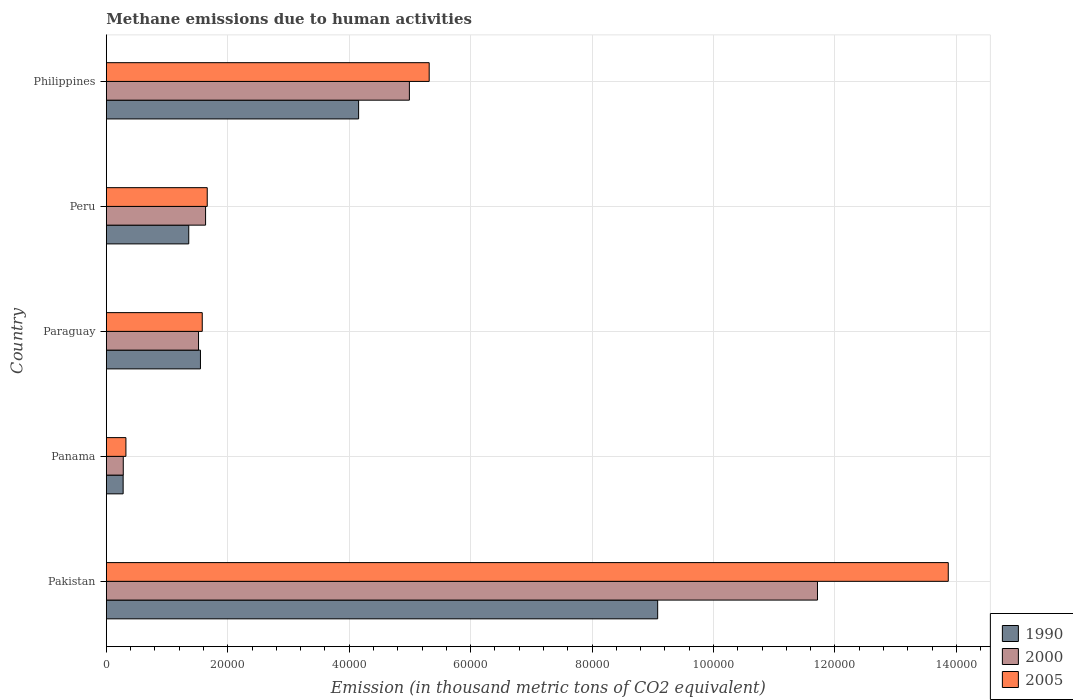How many different coloured bars are there?
Ensure brevity in your answer.  3. How many groups of bars are there?
Offer a very short reply. 5. Are the number of bars per tick equal to the number of legend labels?
Your answer should be compact. Yes. Are the number of bars on each tick of the Y-axis equal?
Your response must be concise. Yes. How many bars are there on the 3rd tick from the bottom?
Offer a very short reply. 3. In how many cases, is the number of bars for a given country not equal to the number of legend labels?
Make the answer very short. 0. What is the amount of methane emitted in 2005 in Pakistan?
Give a very brief answer. 1.39e+05. Across all countries, what is the maximum amount of methane emitted in 2000?
Provide a short and direct response. 1.17e+05. Across all countries, what is the minimum amount of methane emitted in 1990?
Provide a short and direct response. 2769.4. In which country was the amount of methane emitted in 2005 maximum?
Give a very brief answer. Pakistan. In which country was the amount of methane emitted in 2000 minimum?
Ensure brevity in your answer.  Panama. What is the total amount of methane emitted in 2000 in the graph?
Keep it short and to the point. 2.01e+05. What is the difference between the amount of methane emitted in 2000 in Panama and that in Peru?
Provide a succinct answer. -1.36e+04. What is the difference between the amount of methane emitted in 2000 in Peru and the amount of methane emitted in 1990 in Paraguay?
Your answer should be compact. 844.3. What is the average amount of methane emitted in 1990 per country?
Provide a short and direct response. 3.28e+04. What is the difference between the amount of methane emitted in 2000 and amount of methane emitted in 2005 in Panama?
Offer a terse response. -436. In how many countries, is the amount of methane emitted in 2005 greater than 140000 thousand metric tons?
Provide a short and direct response. 0. What is the ratio of the amount of methane emitted in 2000 in Panama to that in Paraguay?
Your answer should be very brief. 0.18. Is the amount of methane emitted in 2005 in Pakistan less than that in Paraguay?
Provide a short and direct response. No. What is the difference between the highest and the second highest amount of methane emitted in 1990?
Keep it short and to the point. 4.93e+04. What is the difference between the highest and the lowest amount of methane emitted in 2005?
Your response must be concise. 1.35e+05. In how many countries, is the amount of methane emitted in 2005 greater than the average amount of methane emitted in 2005 taken over all countries?
Offer a very short reply. 2. What does the 3rd bar from the bottom in Peru represents?
Your answer should be very brief. 2005. Is it the case that in every country, the sum of the amount of methane emitted in 1990 and amount of methane emitted in 2000 is greater than the amount of methane emitted in 2005?
Give a very brief answer. Yes. How many bars are there?
Give a very brief answer. 15. Are all the bars in the graph horizontal?
Your answer should be compact. Yes. What is the difference between two consecutive major ticks on the X-axis?
Provide a succinct answer. 2.00e+04. Does the graph contain grids?
Offer a terse response. Yes. Where does the legend appear in the graph?
Your response must be concise. Bottom right. How many legend labels are there?
Your answer should be very brief. 3. What is the title of the graph?
Ensure brevity in your answer.  Methane emissions due to human activities. What is the label or title of the X-axis?
Give a very brief answer. Emission (in thousand metric tons of CO2 equivalent). What is the Emission (in thousand metric tons of CO2 equivalent) of 1990 in Pakistan?
Offer a very short reply. 9.08e+04. What is the Emission (in thousand metric tons of CO2 equivalent) in 2000 in Pakistan?
Your answer should be compact. 1.17e+05. What is the Emission (in thousand metric tons of CO2 equivalent) of 2005 in Pakistan?
Your answer should be compact. 1.39e+05. What is the Emission (in thousand metric tons of CO2 equivalent) of 1990 in Panama?
Provide a succinct answer. 2769.4. What is the Emission (in thousand metric tons of CO2 equivalent) of 2000 in Panama?
Ensure brevity in your answer.  2789.9. What is the Emission (in thousand metric tons of CO2 equivalent) of 2005 in Panama?
Offer a terse response. 3225.9. What is the Emission (in thousand metric tons of CO2 equivalent) in 1990 in Paraguay?
Offer a terse response. 1.55e+04. What is the Emission (in thousand metric tons of CO2 equivalent) of 2000 in Paraguay?
Ensure brevity in your answer.  1.52e+04. What is the Emission (in thousand metric tons of CO2 equivalent) of 2005 in Paraguay?
Ensure brevity in your answer.  1.58e+04. What is the Emission (in thousand metric tons of CO2 equivalent) in 1990 in Peru?
Ensure brevity in your answer.  1.36e+04. What is the Emission (in thousand metric tons of CO2 equivalent) of 2000 in Peru?
Offer a very short reply. 1.63e+04. What is the Emission (in thousand metric tons of CO2 equivalent) of 2005 in Peru?
Keep it short and to the point. 1.66e+04. What is the Emission (in thousand metric tons of CO2 equivalent) in 1990 in Philippines?
Offer a very short reply. 4.16e+04. What is the Emission (in thousand metric tons of CO2 equivalent) of 2000 in Philippines?
Provide a short and direct response. 4.99e+04. What is the Emission (in thousand metric tons of CO2 equivalent) in 2005 in Philippines?
Your response must be concise. 5.32e+04. Across all countries, what is the maximum Emission (in thousand metric tons of CO2 equivalent) of 1990?
Provide a short and direct response. 9.08e+04. Across all countries, what is the maximum Emission (in thousand metric tons of CO2 equivalent) of 2000?
Offer a very short reply. 1.17e+05. Across all countries, what is the maximum Emission (in thousand metric tons of CO2 equivalent) in 2005?
Provide a succinct answer. 1.39e+05. Across all countries, what is the minimum Emission (in thousand metric tons of CO2 equivalent) of 1990?
Your answer should be very brief. 2769.4. Across all countries, what is the minimum Emission (in thousand metric tons of CO2 equivalent) in 2000?
Provide a succinct answer. 2789.9. Across all countries, what is the minimum Emission (in thousand metric tons of CO2 equivalent) in 2005?
Offer a terse response. 3225.9. What is the total Emission (in thousand metric tons of CO2 equivalent) in 1990 in the graph?
Ensure brevity in your answer.  1.64e+05. What is the total Emission (in thousand metric tons of CO2 equivalent) of 2000 in the graph?
Give a very brief answer. 2.01e+05. What is the total Emission (in thousand metric tons of CO2 equivalent) in 2005 in the graph?
Keep it short and to the point. 2.27e+05. What is the difference between the Emission (in thousand metric tons of CO2 equivalent) of 1990 in Pakistan and that in Panama?
Ensure brevity in your answer.  8.80e+04. What is the difference between the Emission (in thousand metric tons of CO2 equivalent) in 2000 in Pakistan and that in Panama?
Ensure brevity in your answer.  1.14e+05. What is the difference between the Emission (in thousand metric tons of CO2 equivalent) of 2005 in Pakistan and that in Panama?
Provide a succinct answer. 1.35e+05. What is the difference between the Emission (in thousand metric tons of CO2 equivalent) in 1990 in Pakistan and that in Paraguay?
Provide a succinct answer. 7.53e+04. What is the difference between the Emission (in thousand metric tons of CO2 equivalent) of 2000 in Pakistan and that in Paraguay?
Keep it short and to the point. 1.02e+05. What is the difference between the Emission (in thousand metric tons of CO2 equivalent) in 2005 in Pakistan and that in Paraguay?
Ensure brevity in your answer.  1.23e+05. What is the difference between the Emission (in thousand metric tons of CO2 equivalent) in 1990 in Pakistan and that in Peru?
Give a very brief answer. 7.72e+04. What is the difference between the Emission (in thousand metric tons of CO2 equivalent) in 2000 in Pakistan and that in Peru?
Your answer should be compact. 1.01e+05. What is the difference between the Emission (in thousand metric tons of CO2 equivalent) in 2005 in Pakistan and that in Peru?
Provide a short and direct response. 1.22e+05. What is the difference between the Emission (in thousand metric tons of CO2 equivalent) of 1990 in Pakistan and that in Philippines?
Offer a terse response. 4.93e+04. What is the difference between the Emission (in thousand metric tons of CO2 equivalent) in 2000 in Pakistan and that in Philippines?
Give a very brief answer. 6.72e+04. What is the difference between the Emission (in thousand metric tons of CO2 equivalent) in 2005 in Pakistan and that in Philippines?
Give a very brief answer. 8.55e+04. What is the difference between the Emission (in thousand metric tons of CO2 equivalent) of 1990 in Panama and that in Paraguay?
Your answer should be very brief. -1.27e+04. What is the difference between the Emission (in thousand metric tons of CO2 equivalent) of 2000 in Panama and that in Paraguay?
Your answer should be compact. -1.24e+04. What is the difference between the Emission (in thousand metric tons of CO2 equivalent) of 2005 in Panama and that in Paraguay?
Offer a very short reply. -1.26e+04. What is the difference between the Emission (in thousand metric tons of CO2 equivalent) of 1990 in Panama and that in Peru?
Give a very brief answer. -1.08e+04. What is the difference between the Emission (in thousand metric tons of CO2 equivalent) of 2000 in Panama and that in Peru?
Offer a terse response. -1.36e+04. What is the difference between the Emission (in thousand metric tons of CO2 equivalent) in 2005 in Panama and that in Peru?
Offer a very short reply. -1.34e+04. What is the difference between the Emission (in thousand metric tons of CO2 equivalent) in 1990 in Panama and that in Philippines?
Offer a very short reply. -3.88e+04. What is the difference between the Emission (in thousand metric tons of CO2 equivalent) in 2000 in Panama and that in Philippines?
Your answer should be compact. -4.71e+04. What is the difference between the Emission (in thousand metric tons of CO2 equivalent) of 2005 in Panama and that in Philippines?
Ensure brevity in your answer.  -4.99e+04. What is the difference between the Emission (in thousand metric tons of CO2 equivalent) of 1990 in Paraguay and that in Peru?
Make the answer very short. 1927.1. What is the difference between the Emission (in thousand metric tons of CO2 equivalent) of 2000 in Paraguay and that in Peru?
Your response must be concise. -1160.8. What is the difference between the Emission (in thousand metric tons of CO2 equivalent) in 2005 in Paraguay and that in Peru?
Provide a short and direct response. -820.6. What is the difference between the Emission (in thousand metric tons of CO2 equivalent) of 1990 in Paraguay and that in Philippines?
Your response must be concise. -2.61e+04. What is the difference between the Emission (in thousand metric tons of CO2 equivalent) in 2000 in Paraguay and that in Philippines?
Ensure brevity in your answer.  -3.47e+04. What is the difference between the Emission (in thousand metric tons of CO2 equivalent) of 2005 in Paraguay and that in Philippines?
Offer a terse response. -3.74e+04. What is the difference between the Emission (in thousand metric tons of CO2 equivalent) in 1990 in Peru and that in Philippines?
Your response must be concise. -2.80e+04. What is the difference between the Emission (in thousand metric tons of CO2 equivalent) of 2000 in Peru and that in Philippines?
Offer a very short reply. -3.36e+04. What is the difference between the Emission (in thousand metric tons of CO2 equivalent) of 2005 in Peru and that in Philippines?
Offer a very short reply. -3.66e+04. What is the difference between the Emission (in thousand metric tons of CO2 equivalent) of 1990 in Pakistan and the Emission (in thousand metric tons of CO2 equivalent) of 2000 in Panama?
Your response must be concise. 8.80e+04. What is the difference between the Emission (in thousand metric tons of CO2 equivalent) in 1990 in Pakistan and the Emission (in thousand metric tons of CO2 equivalent) in 2005 in Panama?
Give a very brief answer. 8.76e+04. What is the difference between the Emission (in thousand metric tons of CO2 equivalent) of 2000 in Pakistan and the Emission (in thousand metric tons of CO2 equivalent) of 2005 in Panama?
Make the answer very short. 1.14e+05. What is the difference between the Emission (in thousand metric tons of CO2 equivalent) in 1990 in Pakistan and the Emission (in thousand metric tons of CO2 equivalent) in 2000 in Paraguay?
Give a very brief answer. 7.56e+04. What is the difference between the Emission (in thousand metric tons of CO2 equivalent) in 1990 in Pakistan and the Emission (in thousand metric tons of CO2 equivalent) in 2005 in Paraguay?
Keep it short and to the point. 7.50e+04. What is the difference between the Emission (in thousand metric tons of CO2 equivalent) of 2000 in Pakistan and the Emission (in thousand metric tons of CO2 equivalent) of 2005 in Paraguay?
Offer a very short reply. 1.01e+05. What is the difference between the Emission (in thousand metric tons of CO2 equivalent) in 1990 in Pakistan and the Emission (in thousand metric tons of CO2 equivalent) in 2000 in Peru?
Ensure brevity in your answer.  7.45e+04. What is the difference between the Emission (in thousand metric tons of CO2 equivalent) in 1990 in Pakistan and the Emission (in thousand metric tons of CO2 equivalent) in 2005 in Peru?
Ensure brevity in your answer.  7.42e+04. What is the difference between the Emission (in thousand metric tons of CO2 equivalent) in 2000 in Pakistan and the Emission (in thousand metric tons of CO2 equivalent) in 2005 in Peru?
Your answer should be very brief. 1.01e+05. What is the difference between the Emission (in thousand metric tons of CO2 equivalent) of 1990 in Pakistan and the Emission (in thousand metric tons of CO2 equivalent) of 2000 in Philippines?
Provide a short and direct response. 4.09e+04. What is the difference between the Emission (in thousand metric tons of CO2 equivalent) of 1990 in Pakistan and the Emission (in thousand metric tons of CO2 equivalent) of 2005 in Philippines?
Provide a short and direct response. 3.76e+04. What is the difference between the Emission (in thousand metric tons of CO2 equivalent) of 2000 in Pakistan and the Emission (in thousand metric tons of CO2 equivalent) of 2005 in Philippines?
Make the answer very short. 6.40e+04. What is the difference between the Emission (in thousand metric tons of CO2 equivalent) of 1990 in Panama and the Emission (in thousand metric tons of CO2 equivalent) of 2000 in Paraguay?
Your response must be concise. -1.24e+04. What is the difference between the Emission (in thousand metric tons of CO2 equivalent) in 1990 in Panama and the Emission (in thousand metric tons of CO2 equivalent) in 2005 in Paraguay?
Your response must be concise. -1.30e+04. What is the difference between the Emission (in thousand metric tons of CO2 equivalent) in 2000 in Panama and the Emission (in thousand metric tons of CO2 equivalent) in 2005 in Paraguay?
Give a very brief answer. -1.30e+04. What is the difference between the Emission (in thousand metric tons of CO2 equivalent) in 1990 in Panama and the Emission (in thousand metric tons of CO2 equivalent) in 2000 in Peru?
Provide a succinct answer. -1.36e+04. What is the difference between the Emission (in thousand metric tons of CO2 equivalent) of 1990 in Panama and the Emission (in thousand metric tons of CO2 equivalent) of 2005 in Peru?
Provide a succinct answer. -1.38e+04. What is the difference between the Emission (in thousand metric tons of CO2 equivalent) of 2000 in Panama and the Emission (in thousand metric tons of CO2 equivalent) of 2005 in Peru?
Offer a very short reply. -1.38e+04. What is the difference between the Emission (in thousand metric tons of CO2 equivalent) of 1990 in Panama and the Emission (in thousand metric tons of CO2 equivalent) of 2000 in Philippines?
Ensure brevity in your answer.  -4.71e+04. What is the difference between the Emission (in thousand metric tons of CO2 equivalent) of 1990 in Panama and the Emission (in thousand metric tons of CO2 equivalent) of 2005 in Philippines?
Give a very brief answer. -5.04e+04. What is the difference between the Emission (in thousand metric tons of CO2 equivalent) in 2000 in Panama and the Emission (in thousand metric tons of CO2 equivalent) in 2005 in Philippines?
Provide a succinct answer. -5.04e+04. What is the difference between the Emission (in thousand metric tons of CO2 equivalent) of 1990 in Paraguay and the Emission (in thousand metric tons of CO2 equivalent) of 2000 in Peru?
Your answer should be compact. -844.3. What is the difference between the Emission (in thousand metric tons of CO2 equivalent) in 1990 in Paraguay and the Emission (in thousand metric tons of CO2 equivalent) in 2005 in Peru?
Your response must be concise. -1118.2. What is the difference between the Emission (in thousand metric tons of CO2 equivalent) of 2000 in Paraguay and the Emission (in thousand metric tons of CO2 equivalent) of 2005 in Peru?
Provide a short and direct response. -1434.7. What is the difference between the Emission (in thousand metric tons of CO2 equivalent) in 1990 in Paraguay and the Emission (in thousand metric tons of CO2 equivalent) in 2000 in Philippines?
Keep it short and to the point. -3.44e+04. What is the difference between the Emission (in thousand metric tons of CO2 equivalent) in 1990 in Paraguay and the Emission (in thousand metric tons of CO2 equivalent) in 2005 in Philippines?
Keep it short and to the point. -3.77e+04. What is the difference between the Emission (in thousand metric tons of CO2 equivalent) in 2000 in Paraguay and the Emission (in thousand metric tons of CO2 equivalent) in 2005 in Philippines?
Make the answer very short. -3.80e+04. What is the difference between the Emission (in thousand metric tons of CO2 equivalent) in 1990 in Peru and the Emission (in thousand metric tons of CO2 equivalent) in 2000 in Philippines?
Ensure brevity in your answer.  -3.63e+04. What is the difference between the Emission (in thousand metric tons of CO2 equivalent) of 1990 in Peru and the Emission (in thousand metric tons of CO2 equivalent) of 2005 in Philippines?
Your response must be concise. -3.96e+04. What is the difference between the Emission (in thousand metric tons of CO2 equivalent) in 2000 in Peru and the Emission (in thousand metric tons of CO2 equivalent) in 2005 in Philippines?
Offer a terse response. -3.68e+04. What is the average Emission (in thousand metric tons of CO2 equivalent) of 1990 per country?
Offer a very short reply. 3.28e+04. What is the average Emission (in thousand metric tons of CO2 equivalent) in 2000 per country?
Offer a terse response. 4.03e+04. What is the average Emission (in thousand metric tons of CO2 equivalent) of 2005 per country?
Make the answer very short. 4.55e+04. What is the difference between the Emission (in thousand metric tons of CO2 equivalent) in 1990 and Emission (in thousand metric tons of CO2 equivalent) in 2000 in Pakistan?
Provide a succinct answer. -2.63e+04. What is the difference between the Emission (in thousand metric tons of CO2 equivalent) in 1990 and Emission (in thousand metric tons of CO2 equivalent) in 2005 in Pakistan?
Provide a short and direct response. -4.79e+04. What is the difference between the Emission (in thousand metric tons of CO2 equivalent) in 2000 and Emission (in thousand metric tons of CO2 equivalent) in 2005 in Pakistan?
Your response must be concise. -2.15e+04. What is the difference between the Emission (in thousand metric tons of CO2 equivalent) of 1990 and Emission (in thousand metric tons of CO2 equivalent) of 2000 in Panama?
Ensure brevity in your answer.  -20.5. What is the difference between the Emission (in thousand metric tons of CO2 equivalent) of 1990 and Emission (in thousand metric tons of CO2 equivalent) of 2005 in Panama?
Keep it short and to the point. -456.5. What is the difference between the Emission (in thousand metric tons of CO2 equivalent) in 2000 and Emission (in thousand metric tons of CO2 equivalent) in 2005 in Panama?
Your response must be concise. -436. What is the difference between the Emission (in thousand metric tons of CO2 equivalent) of 1990 and Emission (in thousand metric tons of CO2 equivalent) of 2000 in Paraguay?
Offer a very short reply. 316.5. What is the difference between the Emission (in thousand metric tons of CO2 equivalent) in 1990 and Emission (in thousand metric tons of CO2 equivalent) in 2005 in Paraguay?
Offer a very short reply. -297.6. What is the difference between the Emission (in thousand metric tons of CO2 equivalent) of 2000 and Emission (in thousand metric tons of CO2 equivalent) of 2005 in Paraguay?
Provide a short and direct response. -614.1. What is the difference between the Emission (in thousand metric tons of CO2 equivalent) of 1990 and Emission (in thousand metric tons of CO2 equivalent) of 2000 in Peru?
Ensure brevity in your answer.  -2771.4. What is the difference between the Emission (in thousand metric tons of CO2 equivalent) in 1990 and Emission (in thousand metric tons of CO2 equivalent) in 2005 in Peru?
Make the answer very short. -3045.3. What is the difference between the Emission (in thousand metric tons of CO2 equivalent) in 2000 and Emission (in thousand metric tons of CO2 equivalent) in 2005 in Peru?
Keep it short and to the point. -273.9. What is the difference between the Emission (in thousand metric tons of CO2 equivalent) in 1990 and Emission (in thousand metric tons of CO2 equivalent) in 2000 in Philippines?
Offer a terse response. -8363.6. What is the difference between the Emission (in thousand metric tons of CO2 equivalent) of 1990 and Emission (in thousand metric tons of CO2 equivalent) of 2005 in Philippines?
Offer a terse response. -1.16e+04. What is the difference between the Emission (in thousand metric tons of CO2 equivalent) in 2000 and Emission (in thousand metric tons of CO2 equivalent) in 2005 in Philippines?
Your answer should be very brief. -3260.6. What is the ratio of the Emission (in thousand metric tons of CO2 equivalent) in 1990 in Pakistan to that in Panama?
Offer a very short reply. 32.79. What is the ratio of the Emission (in thousand metric tons of CO2 equivalent) of 2000 in Pakistan to that in Panama?
Provide a succinct answer. 41.98. What is the ratio of the Emission (in thousand metric tons of CO2 equivalent) of 2005 in Pakistan to that in Panama?
Provide a short and direct response. 42.99. What is the ratio of the Emission (in thousand metric tons of CO2 equivalent) in 1990 in Pakistan to that in Paraguay?
Offer a very short reply. 5.86. What is the ratio of the Emission (in thousand metric tons of CO2 equivalent) in 2000 in Pakistan to that in Paraguay?
Your answer should be very brief. 7.71. What is the ratio of the Emission (in thousand metric tons of CO2 equivalent) of 2005 in Pakistan to that in Paraguay?
Make the answer very short. 8.78. What is the ratio of the Emission (in thousand metric tons of CO2 equivalent) of 1990 in Pakistan to that in Peru?
Provide a succinct answer. 6.69. What is the ratio of the Emission (in thousand metric tons of CO2 equivalent) of 2000 in Pakistan to that in Peru?
Provide a succinct answer. 7.17. What is the ratio of the Emission (in thousand metric tons of CO2 equivalent) in 2005 in Pakistan to that in Peru?
Your answer should be compact. 8.34. What is the ratio of the Emission (in thousand metric tons of CO2 equivalent) in 1990 in Pakistan to that in Philippines?
Keep it short and to the point. 2.19. What is the ratio of the Emission (in thousand metric tons of CO2 equivalent) of 2000 in Pakistan to that in Philippines?
Keep it short and to the point. 2.35. What is the ratio of the Emission (in thousand metric tons of CO2 equivalent) in 2005 in Pakistan to that in Philippines?
Keep it short and to the point. 2.61. What is the ratio of the Emission (in thousand metric tons of CO2 equivalent) in 1990 in Panama to that in Paraguay?
Offer a terse response. 0.18. What is the ratio of the Emission (in thousand metric tons of CO2 equivalent) of 2000 in Panama to that in Paraguay?
Give a very brief answer. 0.18. What is the ratio of the Emission (in thousand metric tons of CO2 equivalent) in 2005 in Panama to that in Paraguay?
Keep it short and to the point. 0.2. What is the ratio of the Emission (in thousand metric tons of CO2 equivalent) in 1990 in Panama to that in Peru?
Keep it short and to the point. 0.2. What is the ratio of the Emission (in thousand metric tons of CO2 equivalent) in 2000 in Panama to that in Peru?
Keep it short and to the point. 0.17. What is the ratio of the Emission (in thousand metric tons of CO2 equivalent) of 2005 in Panama to that in Peru?
Your answer should be very brief. 0.19. What is the ratio of the Emission (in thousand metric tons of CO2 equivalent) of 1990 in Panama to that in Philippines?
Offer a terse response. 0.07. What is the ratio of the Emission (in thousand metric tons of CO2 equivalent) in 2000 in Panama to that in Philippines?
Give a very brief answer. 0.06. What is the ratio of the Emission (in thousand metric tons of CO2 equivalent) of 2005 in Panama to that in Philippines?
Offer a terse response. 0.06. What is the ratio of the Emission (in thousand metric tons of CO2 equivalent) of 1990 in Paraguay to that in Peru?
Your answer should be very brief. 1.14. What is the ratio of the Emission (in thousand metric tons of CO2 equivalent) in 2000 in Paraguay to that in Peru?
Provide a short and direct response. 0.93. What is the ratio of the Emission (in thousand metric tons of CO2 equivalent) of 2005 in Paraguay to that in Peru?
Give a very brief answer. 0.95. What is the ratio of the Emission (in thousand metric tons of CO2 equivalent) of 1990 in Paraguay to that in Philippines?
Give a very brief answer. 0.37. What is the ratio of the Emission (in thousand metric tons of CO2 equivalent) in 2000 in Paraguay to that in Philippines?
Keep it short and to the point. 0.3. What is the ratio of the Emission (in thousand metric tons of CO2 equivalent) of 2005 in Paraguay to that in Philippines?
Your answer should be compact. 0.3. What is the ratio of the Emission (in thousand metric tons of CO2 equivalent) of 1990 in Peru to that in Philippines?
Your response must be concise. 0.33. What is the ratio of the Emission (in thousand metric tons of CO2 equivalent) of 2000 in Peru to that in Philippines?
Make the answer very short. 0.33. What is the ratio of the Emission (in thousand metric tons of CO2 equivalent) of 2005 in Peru to that in Philippines?
Your response must be concise. 0.31. What is the difference between the highest and the second highest Emission (in thousand metric tons of CO2 equivalent) in 1990?
Offer a terse response. 4.93e+04. What is the difference between the highest and the second highest Emission (in thousand metric tons of CO2 equivalent) in 2000?
Your response must be concise. 6.72e+04. What is the difference between the highest and the second highest Emission (in thousand metric tons of CO2 equivalent) of 2005?
Give a very brief answer. 8.55e+04. What is the difference between the highest and the lowest Emission (in thousand metric tons of CO2 equivalent) in 1990?
Provide a short and direct response. 8.80e+04. What is the difference between the highest and the lowest Emission (in thousand metric tons of CO2 equivalent) of 2000?
Your answer should be compact. 1.14e+05. What is the difference between the highest and the lowest Emission (in thousand metric tons of CO2 equivalent) in 2005?
Keep it short and to the point. 1.35e+05. 